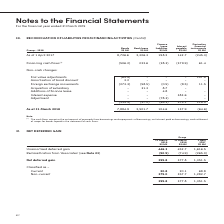According to Singapore Telecommunications's financial document, Why does this net deferred gain balance exist? Based on the financial document, the answer is gain on disposal of Assets recognised by Singtel is deferred in the Group’s statement of financial position and amortised over the useful lives of the Assets. Also, Why is there still a balance of net deferred gain since Singtel sold its 100% interest in NLT to NetLink NBN Trust in July 2017? Based on the financial document, the answer is Singtel ceased to own units in NLT but continues to have an interest of 24.8% in the Trust which owns all the units in NLT. Also, What "Assets" did Singtel sell to NLT? Based on the financial document, the answer is ducts, manholes and exchange buildings. Additionally, In which year was the net deferred gain balance the highest? According to the financial document, 2017. The relevant text states: "As at 1 April 2017 8,726.6 2,306.3 198.2 142.7 (245.3)..." Also, can you calculate: What is the % change in net deferred gain classified under non-current from 2018 to 2019? To answer this question, I need to perform calculations using the financial data. The calculation is: (375.0 - 357.7) / 357.7, which equals 4.84 (percentage). This is based on the information: "lassified as – Current 20.8 20.1 68.8 Non-current 375.0 357.7 1,282.7 ied as – Current 20.8 20.1 68.8 Non-current 375.0 357.7 1,282.7..." The key data points involved are: 357.7, 375.0. Additionally, In which year has the highest % of the net deferred gain classified as current? According to the financial document, 2018. The relevant text states: "Group - 2018 Bonds S$ Mil Bank loans S$ Mil..." 